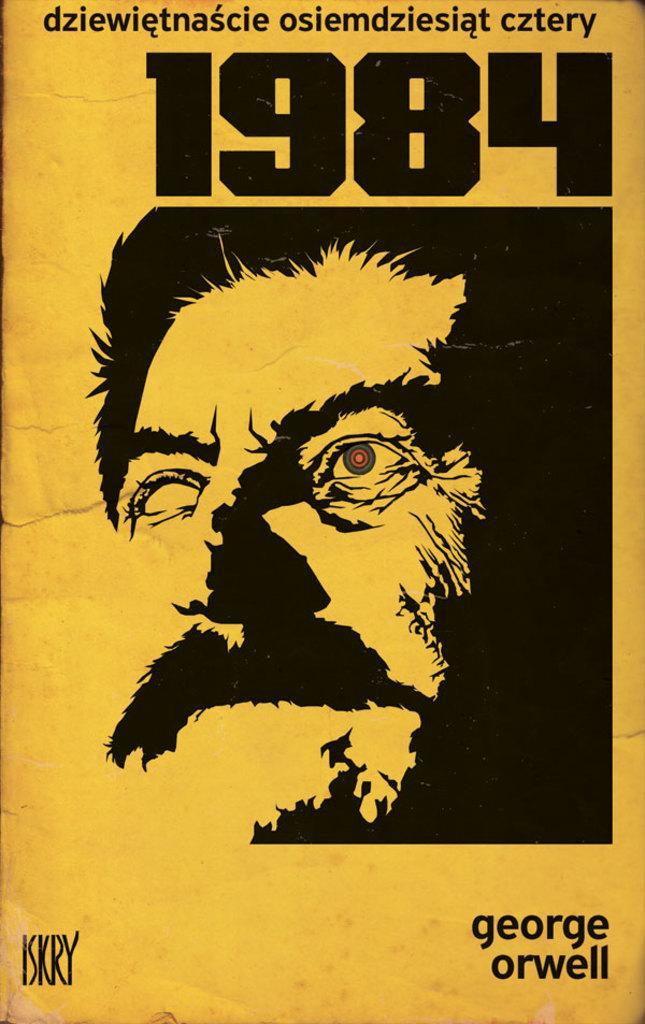In one or two sentences, can you explain what this image depicts? In this image I can see a person face and something is written on it. Background is in yellow color. 